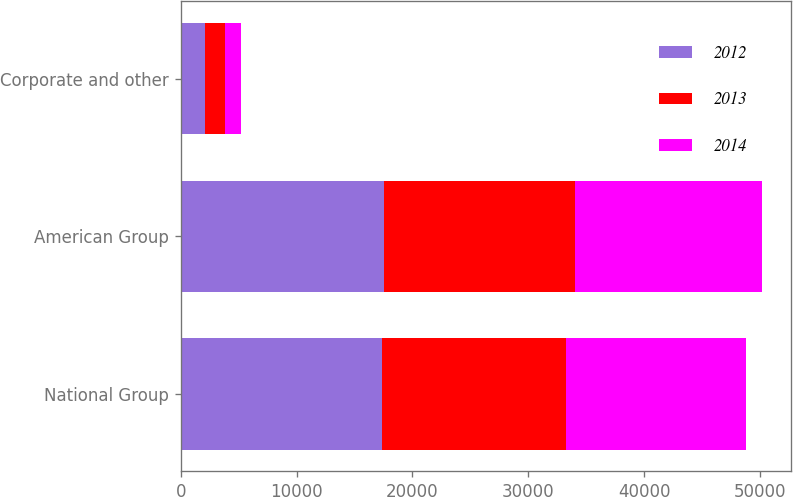Convert chart to OTSL. <chart><loc_0><loc_0><loc_500><loc_500><stacked_bar_chart><ecel><fcel>National Group<fcel>American Group<fcel>Corporate and other<nl><fcel>2012<fcel>17325<fcel>17532<fcel>2061<nl><fcel>2013<fcel>15968<fcel>16487<fcel>1727<nl><fcel>2014<fcel>15505<fcel>16115<fcel>1393<nl></chart> 